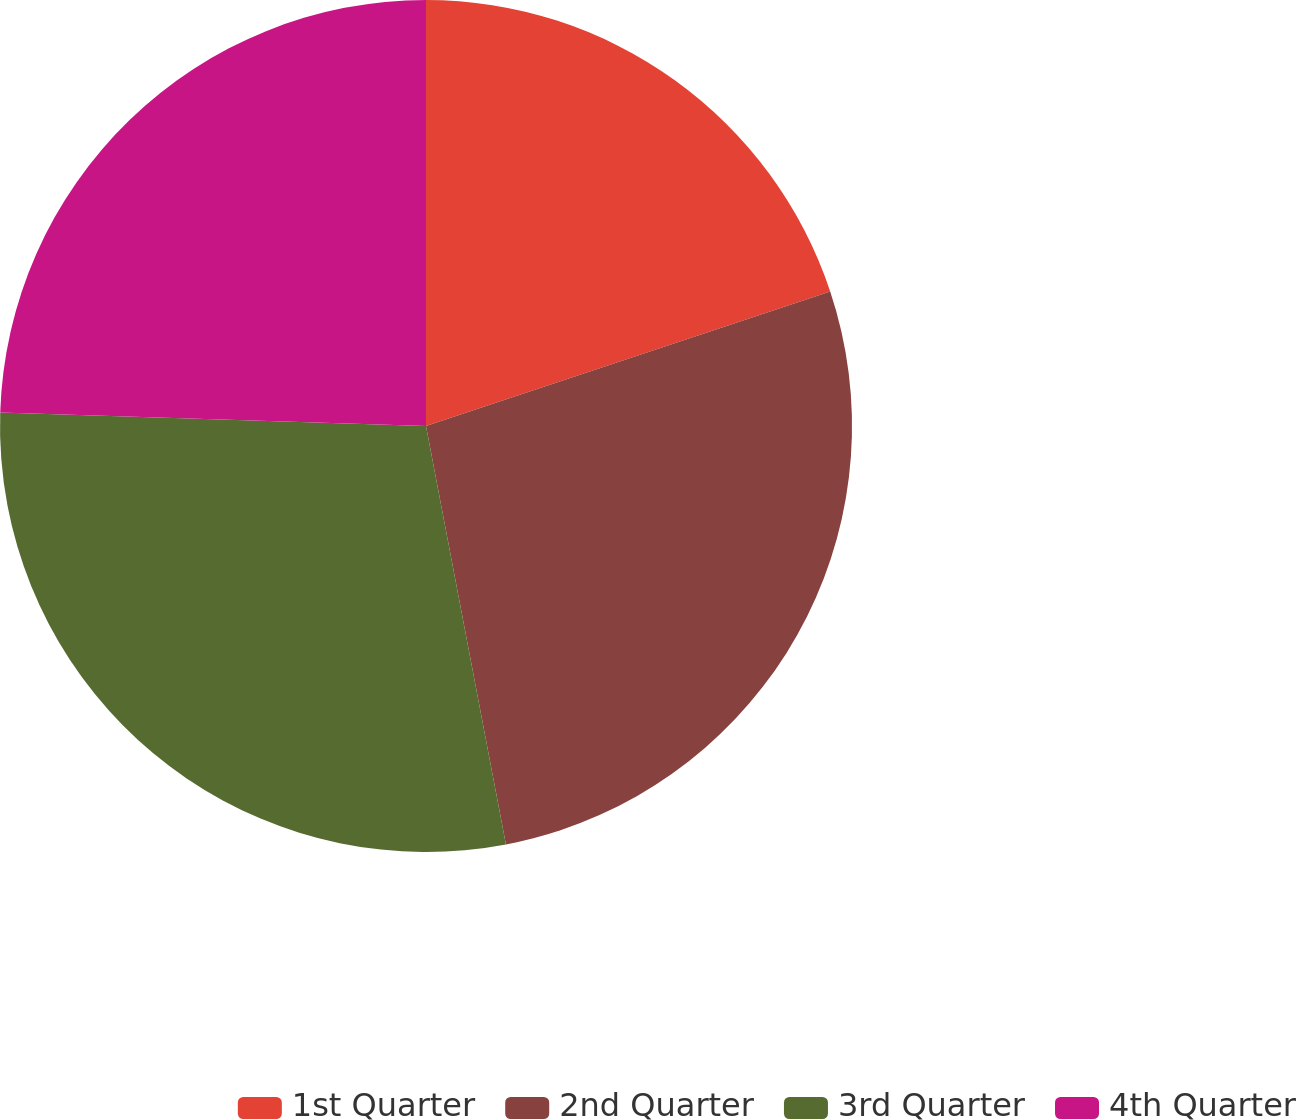<chart> <loc_0><loc_0><loc_500><loc_500><pie_chart><fcel>1st Quarter<fcel>2nd Quarter<fcel>3rd Quarter<fcel>4th Quarter<nl><fcel>19.89%<fcel>27.11%<fcel>28.51%<fcel>24.5%<nl></chart> 